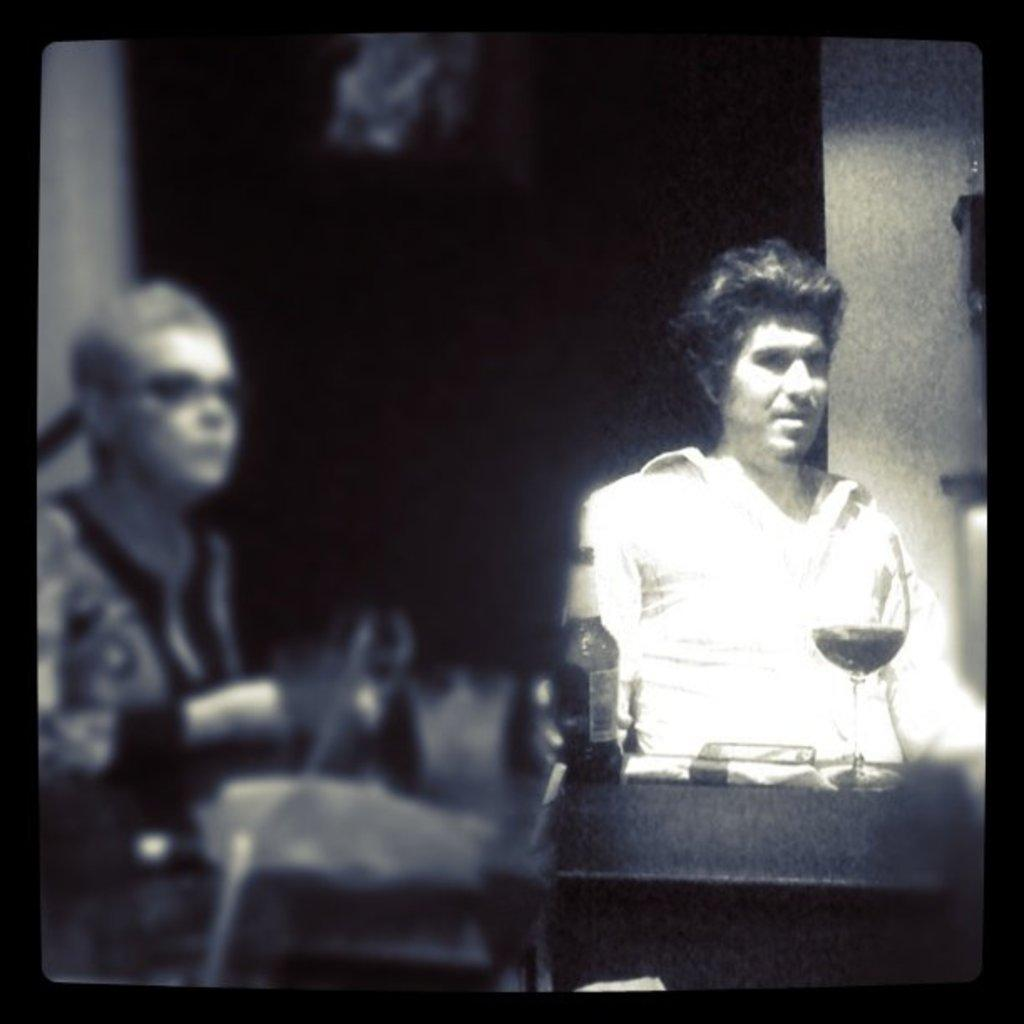How many people are in the image? There are two persons in the image. Where are the two persons located in the image? The two persons are in the center of the image. What type of government apparatus can be seen in the image? There is no government apparatus present in the image. 